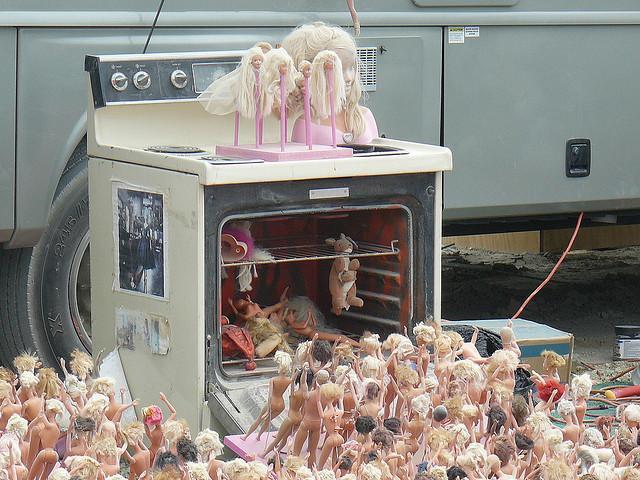How many people are standing up in the photo?
Give a very brief answer. 0. 